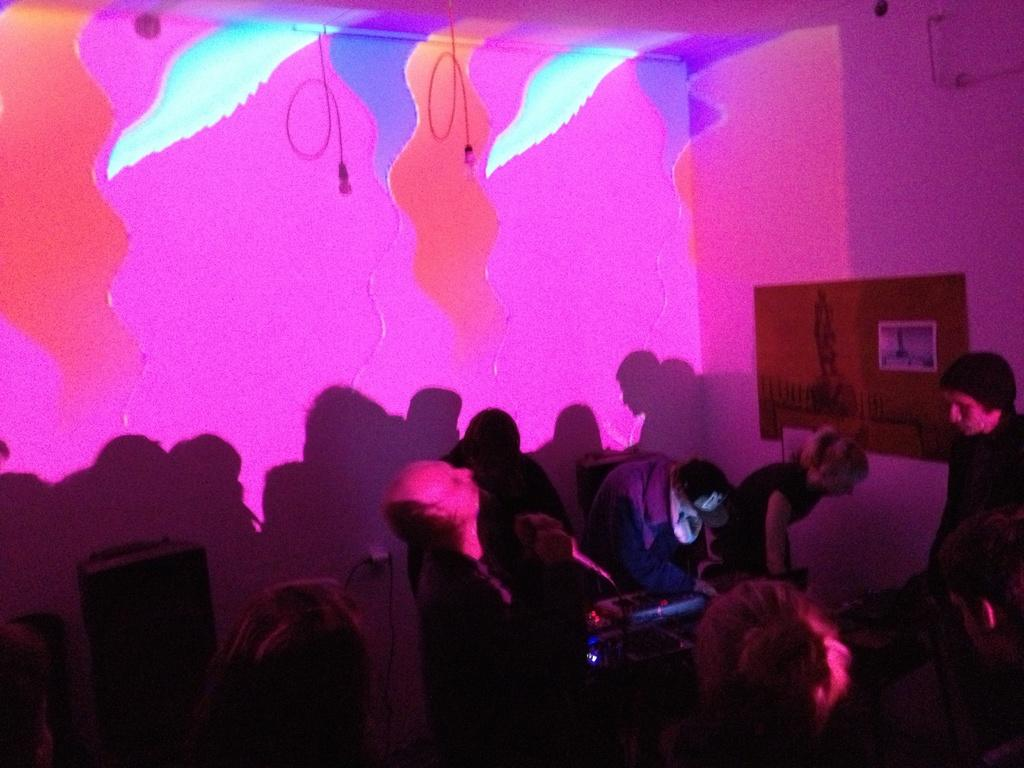How many people are in the image? There is a group of people in the image, but the exact number cannot be determined from the provided facts. What is attached to the wall in the image? There is a board attached to the wall in the image. Can you describe the design on the wall in the image? The design on the wall in the image cannot be described with the given facts. What type of zinc can be seen on the sidewalk in the image? There is no mention of a sidewalk or zinc in the provided facts, so it cannot be determined from the image. 